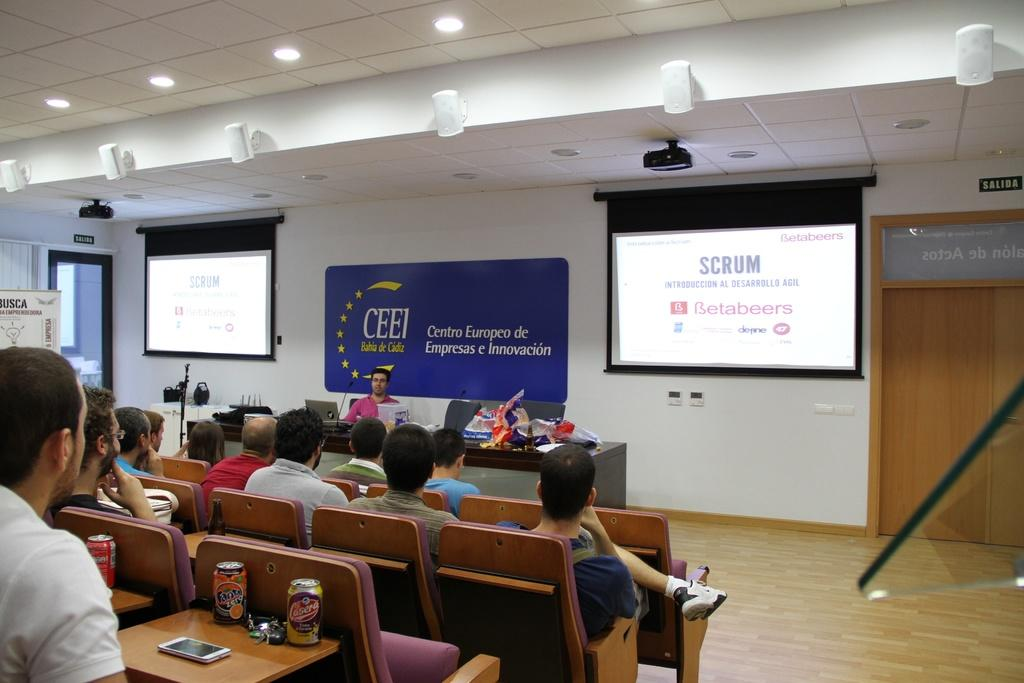What are the people in the room doing? The people in the room are sitting on chairs. How many projectors are in the room? There are two projectors in the room. What are the projectors projecting onto? The projectors are projecting onto two screens in the room. What is used for amplifying sound in the room? There are speakers in the room for amplifying sound. Where is the toad hiding in the room? There is no toad present in the room; the image only features people, chairs, projectors, screens, and speakers. 